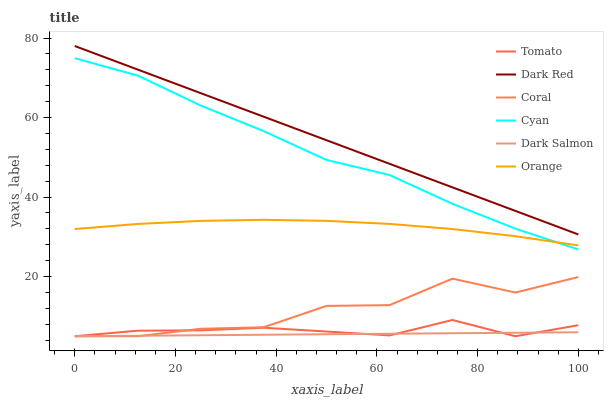Does Dark Salmon have the minimum area under the curve?
Answer yes or no. Yes. Does Dark Red have the maximum area under the curve?
Answer yes or no. Yes. Does Coral have the minimum area under the curve?
Answer yes or no. No. Does Coral have the maximum area under the curve?
Answer yes or no. No. Is Dark Salmon the smoothest?
Answer yes or no. Yes. Is Coral the roughest?
Answer yes or no. Yes. Is Dark Red the smoothest?
Answer yes or no. No. Is Dark Red the roughest?
Answer yes or no. No. Does Dark Red have the lowest value?
Answer yes or no. No. Does Dark Red have the highest value?
Answer yes or no. Yes. Does Coral have the highest value?
Answer yes or no. No. Is Coral less than Dark Red?
Answer yes or no. Yes. Is Cyan greater than Tomato?
Answer yes or no. Yes. Does Coral intersect Tomato?
Answer yes or no. Yes. Is Coral less than Tomato?
Answer yes or no. No. Is Coral greater than Tomato?
Answer yes or no. No. Does Coral intersect Dark Red?
Answer yes or no. No. 